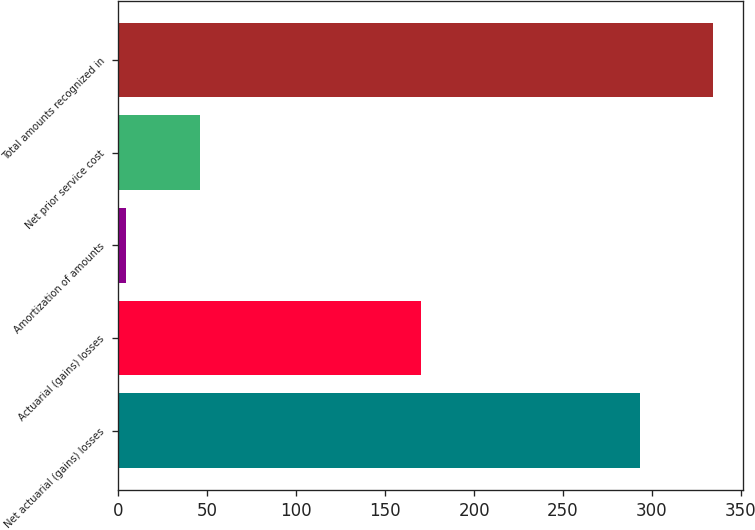Convert chart. <chart><loc_0><loc_0><loc_500><loc_500><bar_chart><fcel>Net actuarial (gains) losses<fcel>Actuarial (gains) losses<fcel>Amortization of amounts<fcel>Net prior service cost<fcel>Total amounts recognized in<nl><fcel>293.2<fcel>169.94<fcel>4.3<fcel>45.71<fcel>334.61<nl></chart> 